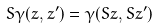Convert formula to latex. <formula><loc_0><loc_0><loc_500><loc_500>S \gamma ( z , z ^ { \prime } ) = \gamma ( S z , S z ^ { \prime } )</formula> 